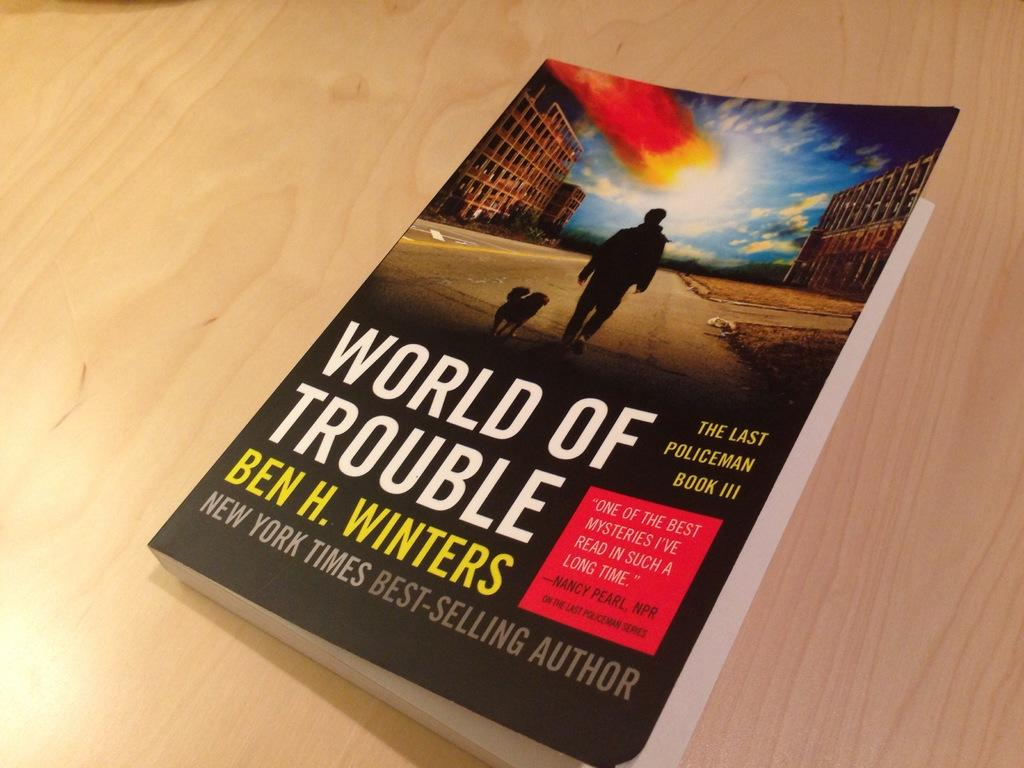<image>
Provide a brief description of the given image. A book by Ben H. Winters called World of Trouble. 